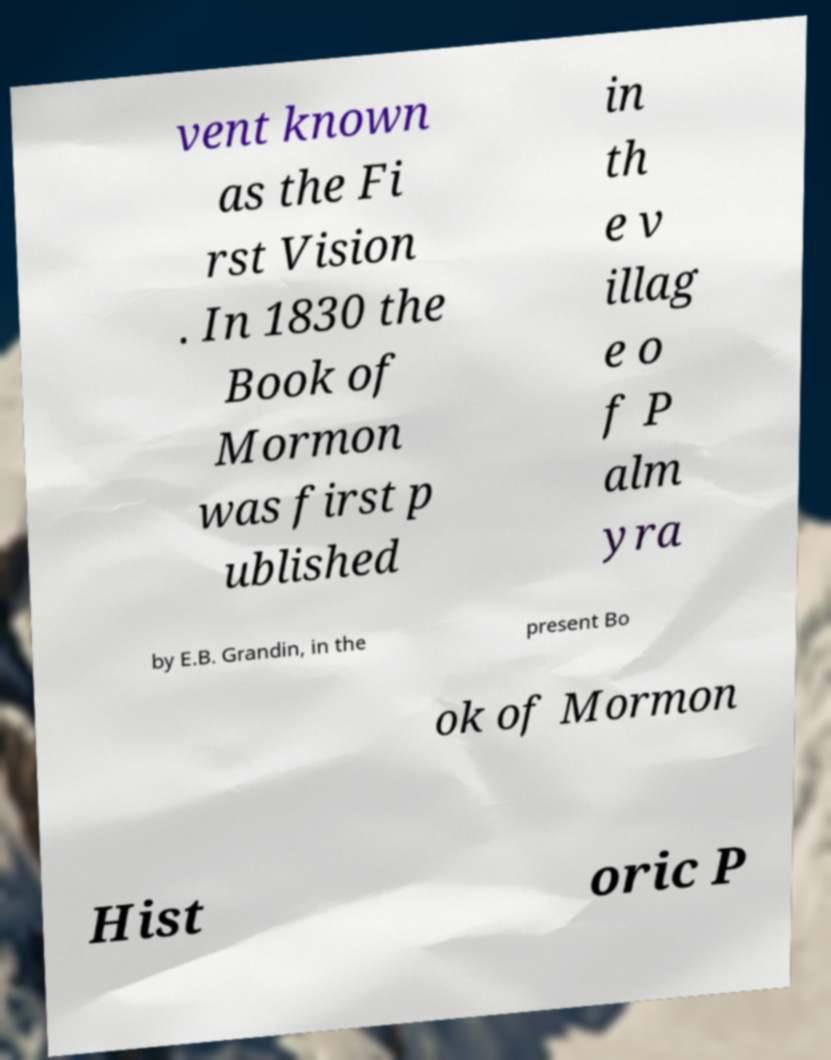Could you extract and type out the text from this image? vent known as the Fi rst Vision . In 1830 the Book of Mormon was first p ublished in th e v illag e o f P alm yra by E.B. Grandin, in the present Bo ok of Mormon Hist oric P 